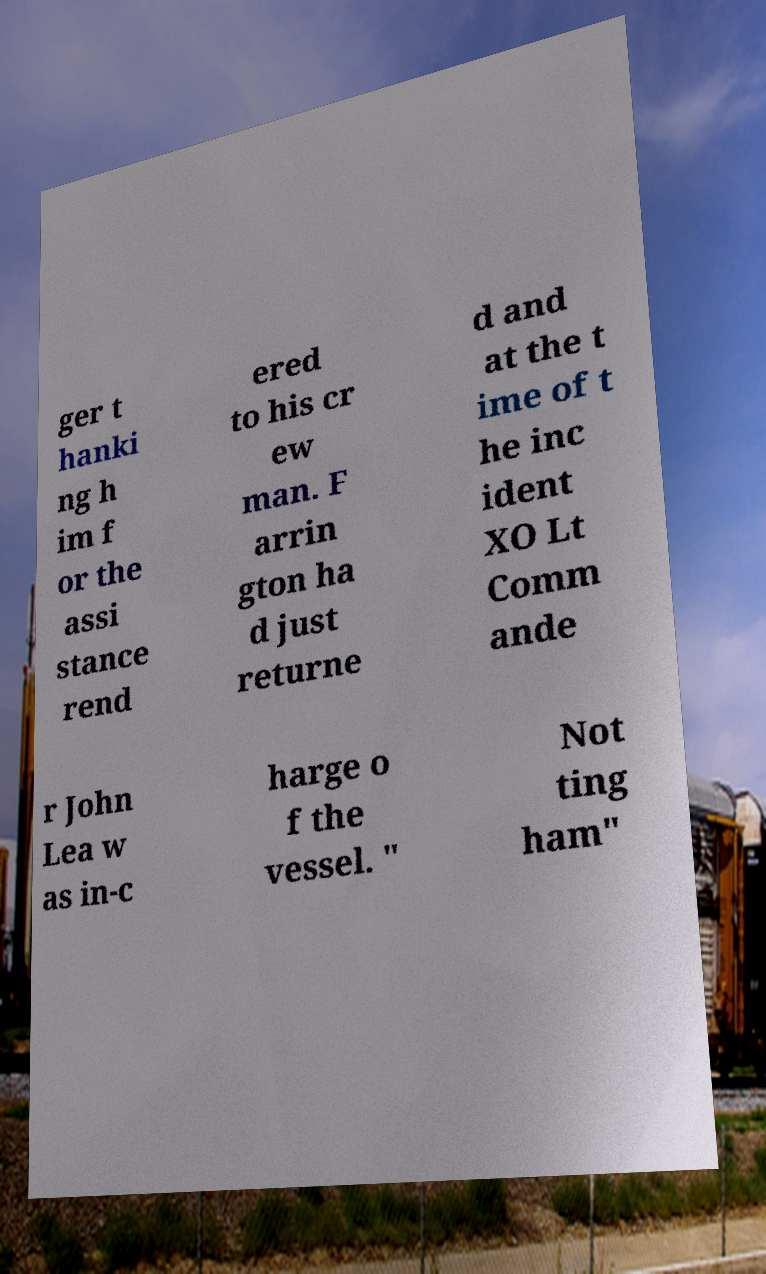Please read and relay the text visible in this image. What does it say? ger t hanki ng h im f or the assi stance rend ered to his cr ew man. F arrin gton ha d just returne d and at the t ime of t he inc ident XO Lt Comm ande r John Lea w as in-c harge o f the vessel. " Not ting ham" 